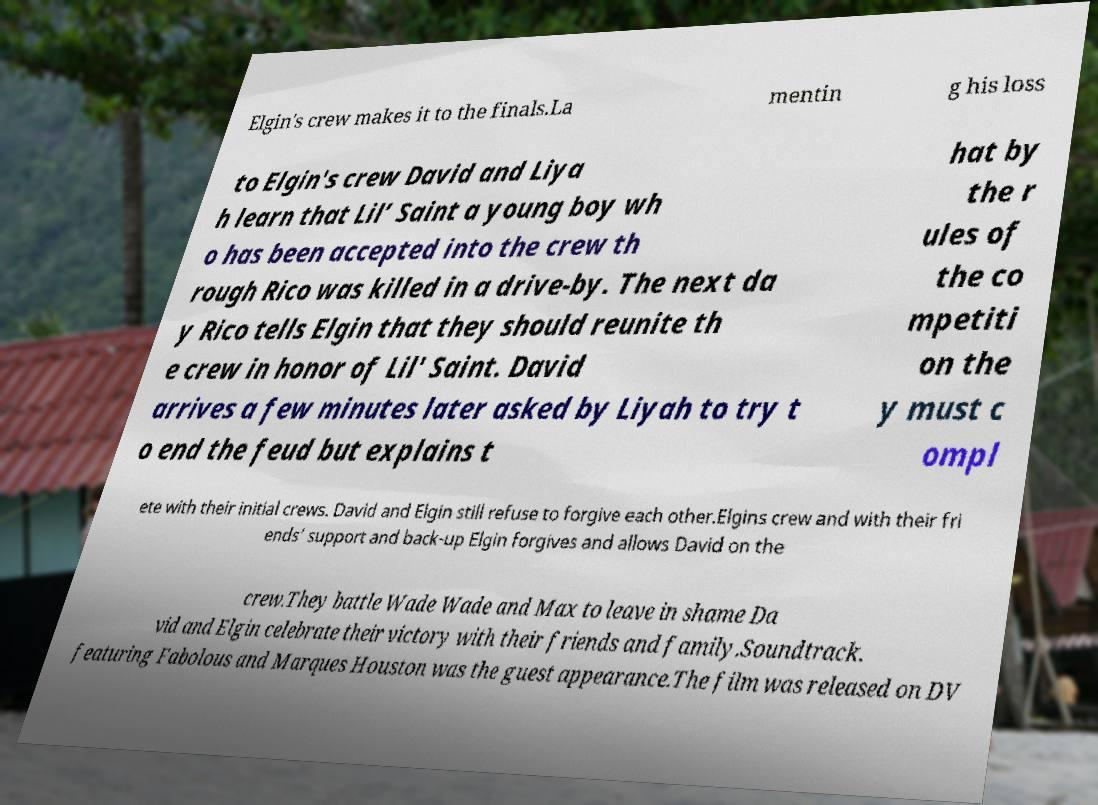Please identify and transcribe the text found in this image. Elgin's crew makes it to the finals.La mentin g his loss to Elgin's crew David and Liya h learn that Lil’ Saint a young boy wh o has been accepted into the crew th rough Rico was killed in a drive-by. The next da y Rico tells Elgin that they should reunite th e crew in honor of Lil' Saint. David arrives a few minutes later asked by Liyah to try t o end the feud but explains t hat by the r ules of the co mpetiti on the y must c ompl ete with their initial crews. David and Elgin still refuse to forgive each other.Elgins crew and with their fri ends’ support and back-up Elgin forgives and allows David on the crew.They battle Wade Wade and Max to leave in shame Da vid and Elgin celebrate their victory with their friends and family.Soundtrack. featuring Fabolous and Marques Houston was the guest appearance.The film was released on DV 